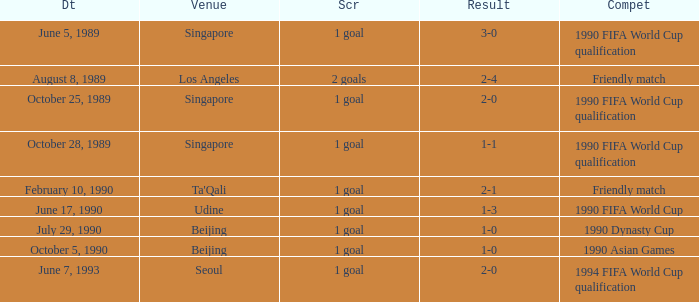What is the competition at the ta'qali venue? Friendly match. 